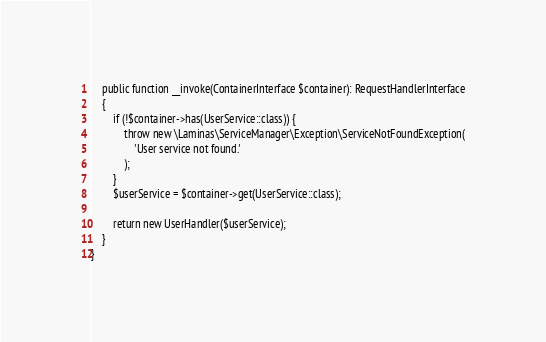Convert code to text. <code><loc_0><loc_0><loc_500><loc_500><_PHP_>    public function __invoke(ContainerInterface $container): RequestHandlerInterface
    {
        if (!$container->has(UserService::class)) {
            throw new \Laminas\ServiceManager\Exception\ServiceNotFoundException(
                'User service not found.'
            );
        }
        $userService = $container->get(UserService::class);

        return new UserHandler($userService);
    }
}
</code> 